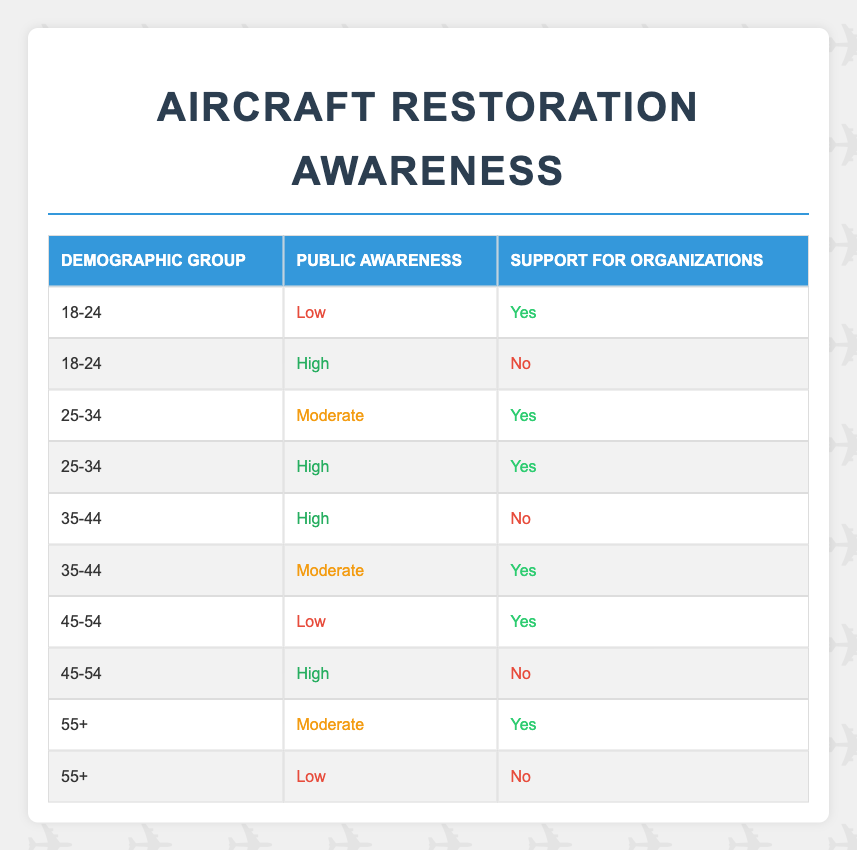What is the demographic group with the highest level of public awareness? By examining the table, the highest level of public awareness is labeled as "High", and it appears in the demographic groups of 25-34 and 35-44. However, there is no group explicitly listed with a higher public awareness than these; therefore, the answer includes those two groups.
Answer: 25-34 and 35-44 How many demographic groups reported high public awareness? The table indicates that two groups (25-34 and 35-44) reported "High" public awareness. Each group is represented once under this category, confirming that there are two such groups.
Answer: 2 Is there any demographic group that has both low public awareness and supports organizations? Upon reviewing the table, the 18-24 and 45-54 demographic groups have low public awareness and do support organizations (marked as "Yes"). This shows that there is indeed at least one group that matches this criteria.
Answer: Yes What is the percentage of groups with moderate public awareness that support organizations? There are three groups with "Moderate" public awareness: 25-34, 35-44, and 55+. Out of these, the groups 25-34 and 35-44 support organizations, totaling two out of three groups. To find the percentage, divide 2 by 3 and multiply by 100, which gives approximately 66.67%.
Answer: 66.67% Among the demographics, who has higher support for the organizations - those with low or moderate public awareness? The demographic groups with low public awareness (18-24 and 45-54) both show support for organizations, yielding a total of 2 groups. In contrast, the moderate category has 25-34, 35-44, and 55+ groups, which includes 2 supporting organizations. Therefore, the support for organizations is equal, but those with low public awareness are fewer in number than those with moderate who support.
Answer: Equal Which demographic group has the least amount of public awareness indicated in the table? Referring to the table, the lowest level of public awareness is marked as "Low". This corresponds to two demographic groups: 18-24 and 55+. However, since each group is counted independently, we say they both represent the least awareness level alongside each other.
Answer: 18-24 and 55+ How many demographic groups have reported not supporting organizations at all? By reviewing the table, the groups that do not support organizations (marked as "No") are 18-24, 35-44, 45-54, and 55+. Counting these rows shows a total of four demographic groups do not support organizations.
Answer: 4 What is the average level of public awareness reported across all demographic groups? The levels of awareness can be numerically encoded as: Low = 1, Moderate = 2, High = 3. Each group represents a level in the table, and by assigning these codes to the 10 entries, I would sum them up (1 + 3 + 2 + 3 + 3 + 2 + 1 + 3 + 2 + 1) = 21. The average is then calculated as 21 divided by 10, yielding an average of 2.1.
Answer: 2.1 